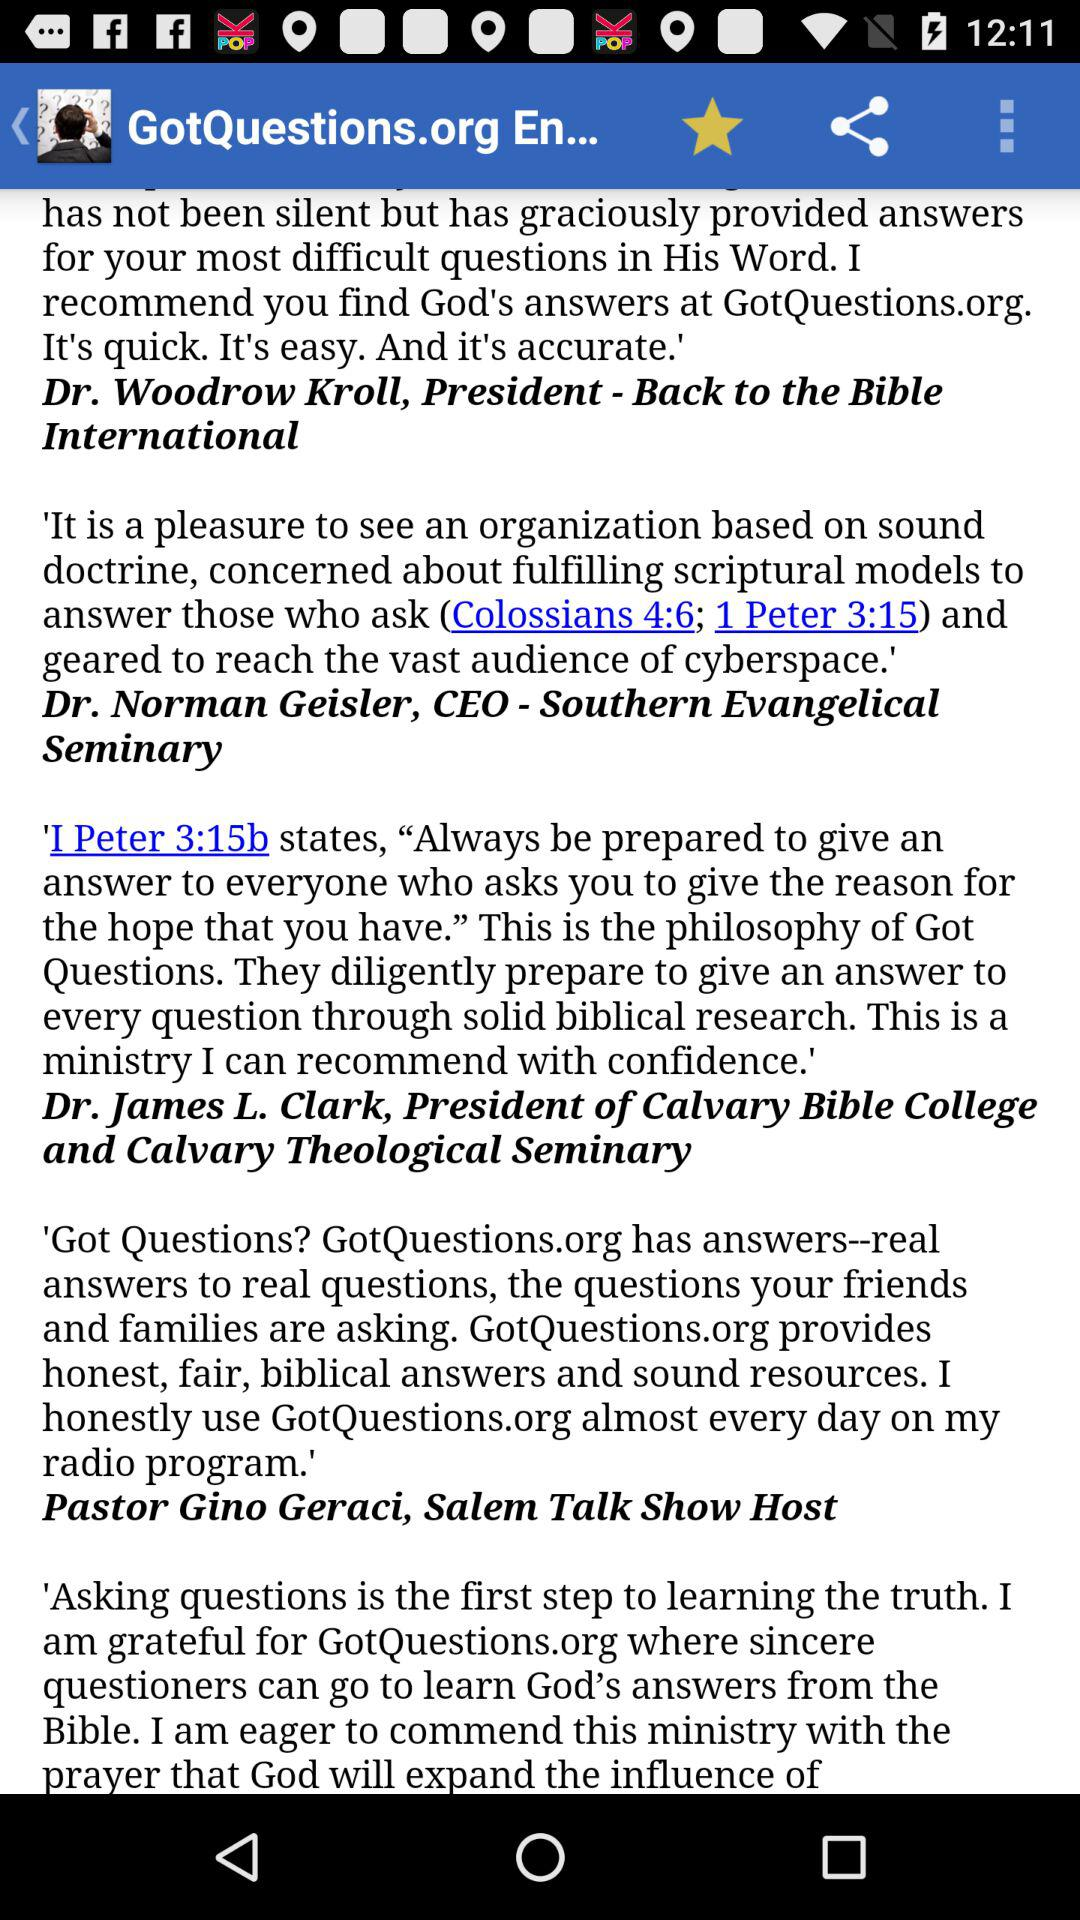Who is the host of the Salem Talk Show? The host of the Salem Talk Show is Pastor Gino Geraci. 